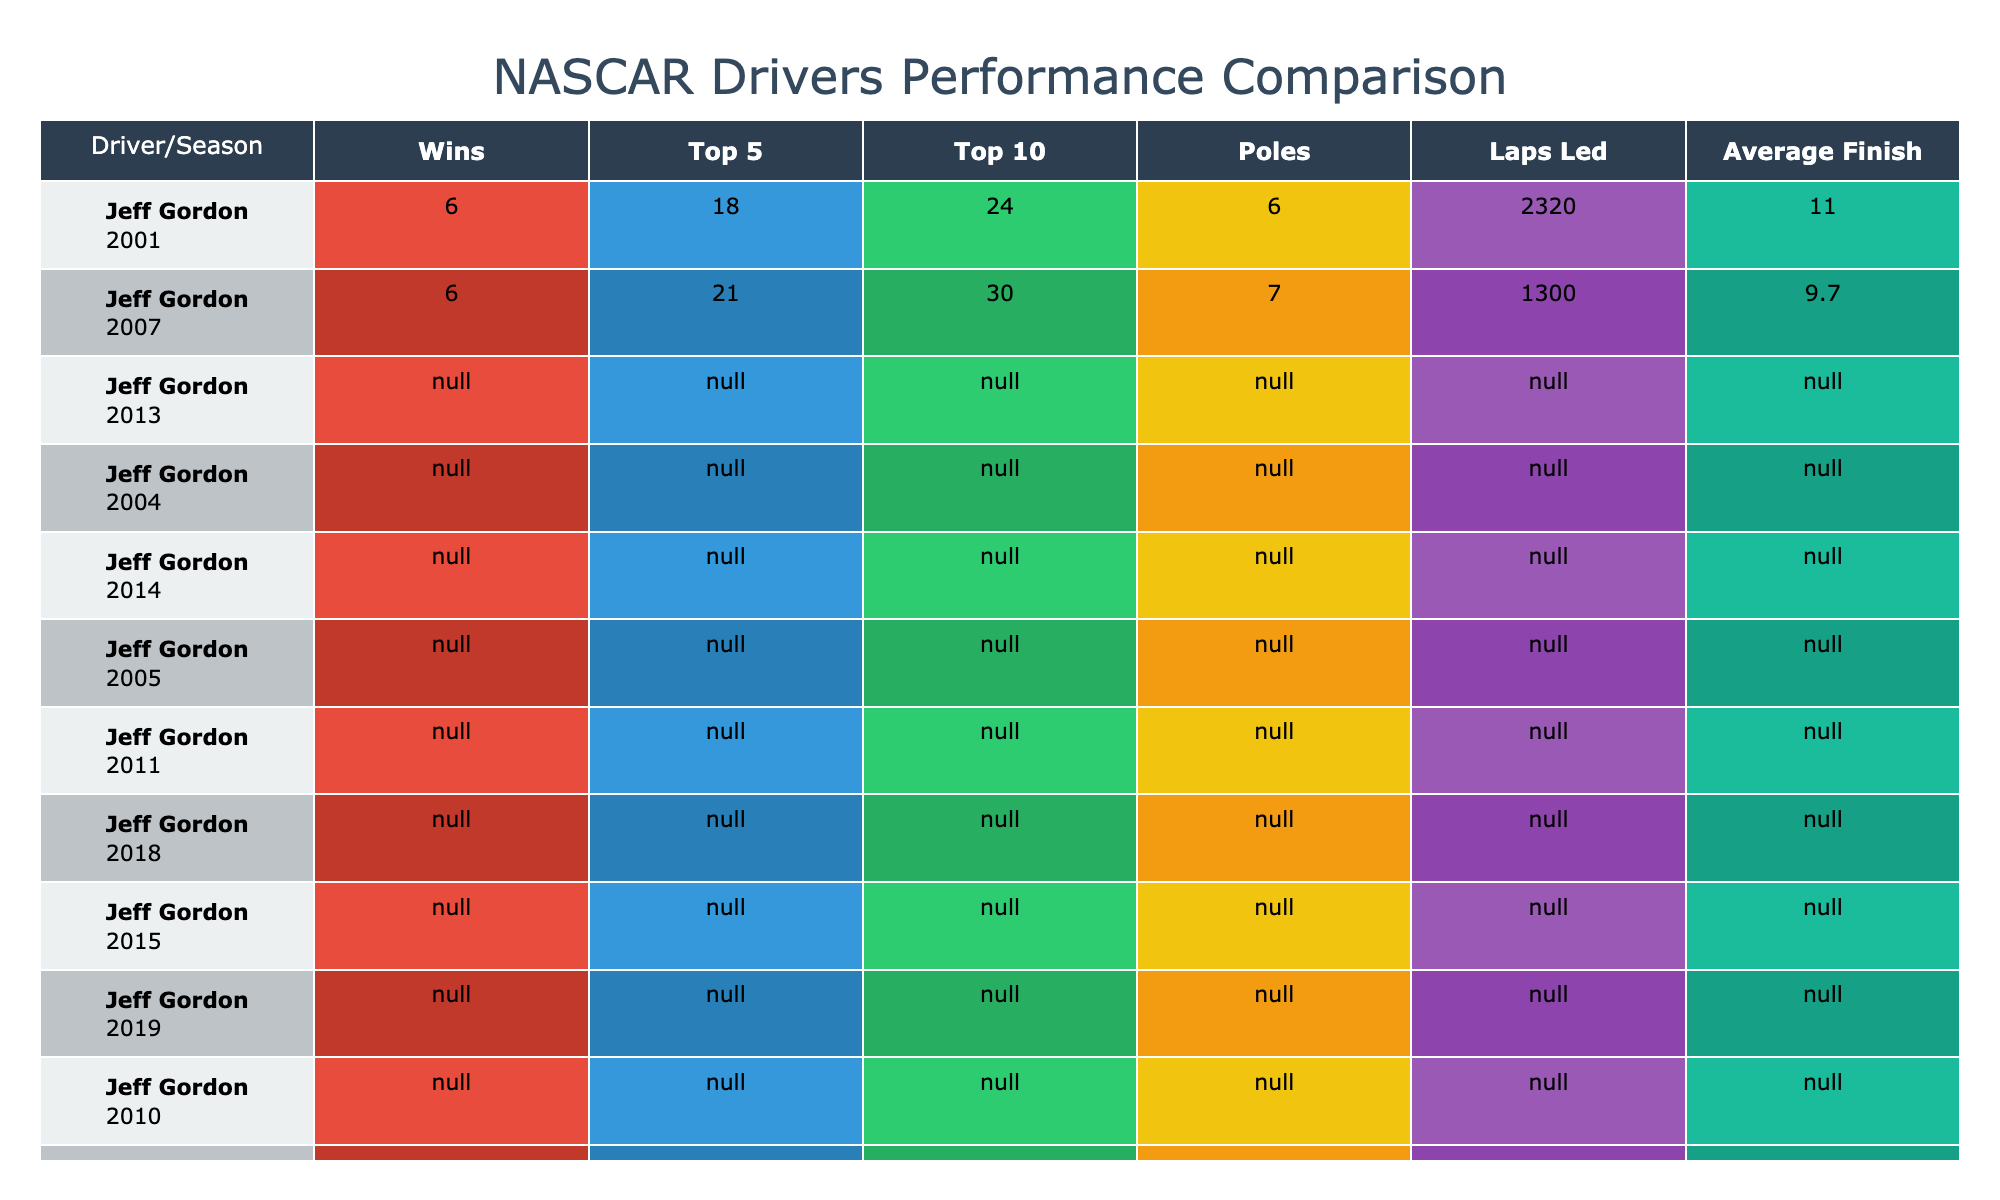What season did Jeff Gordon have the highest average finish? Looking at Jeff Gordon's performance metrics, in 2007 he had an average finish of 9.7, which is lower than his average finish in 2001 (11.0). Therefore, 2007 provided his best average finish.
Answer: 2007 How many wins did Jimmie Johnson achieve in 2007? Directly from the table, Jimmie Johnson is listed with 10 wins in the year 2007.
Answer: 10 What is the total number of top 10 finishes for Dale Earnhardt Jr. across all the seasons listed? Dale Earnhardt Jr. has 21 top 10 finishes in 2004 and 20 in 2014, so the total is 21 + 20 = 41.
Answer: 41 Which driver had the highest number of poles in a single season? Upon examining the table, Kyle Busch had the highest number of poles with 8 in 2014.
Answer: Kyle Busch Did Kyle Busch have more laps led in 2015 or 2019? In 2015, Kyle Busch led 736 laps, while in 2019 he led 1582 laps, indicating that he had more laps led in 2019.
Answer: 2019 What was Tony Stewart's average finish in 2005? By checking the data under Tony Stewart for the year 2005, it shows that he had an average finish of 11.7.
Answer: 11.7 Which driver had fewer total top 5 finishes: Dale Earnhardt Jr. or Kevin Harvick? Dale Earnhardt Jr. had a total of 16 top 5 finishes in 2004 and 12 in 2014, totaling 28. Kevin Harvick had 14 top 5 finishes in 2014 and 23 in 2018, totaling 37. Therefore, Dale Earnhardt Jr. had fewer.
Answer: Dale Earnhardt Jr What is the average number of wins for all drivers listed across their best seasons? The total number of wins is 6 (Gordon, 2001) + 6 (Gordon, 2007) + 10 (Johnson, 2007) + 6 (Johnson, 2013) + 6 (Earnhardt Jr., 2004) + 4 (Earnhardt Jr., 2014) + 5 (Stewart, 2005) + 5 (Stewart, 2011) + 5 (Harvick, 2014) + 8 (Harvick, 2018) + 5 (Busch, 2015) + 5 (Busch, 2019) + 8 (Hamlin, 2010) + 7 (Hamlin, 2020) = 70. There are 14 results, so the average is 70 / 14 = 5.
Answer: 5 How does Denny Hamlin's performance in 2020 compare to his 2010 season in terms of wins? Denny Hamlin had 8 wins in 2010 and 7 wins in 2020, which indicates that he had more wins in 2010 compared to 2020.
Answer: More in 2010 Which driver consistently had an average finish below 11 across the observed seasons? Jeff Gordon achieved an average finish of 9.7 in 2007 and consistently had an average finish of 11.0 in 2001, but no other driver consistently maintained an average finish below 11 across multiple seasons.
Answer: Jeff Gordon 